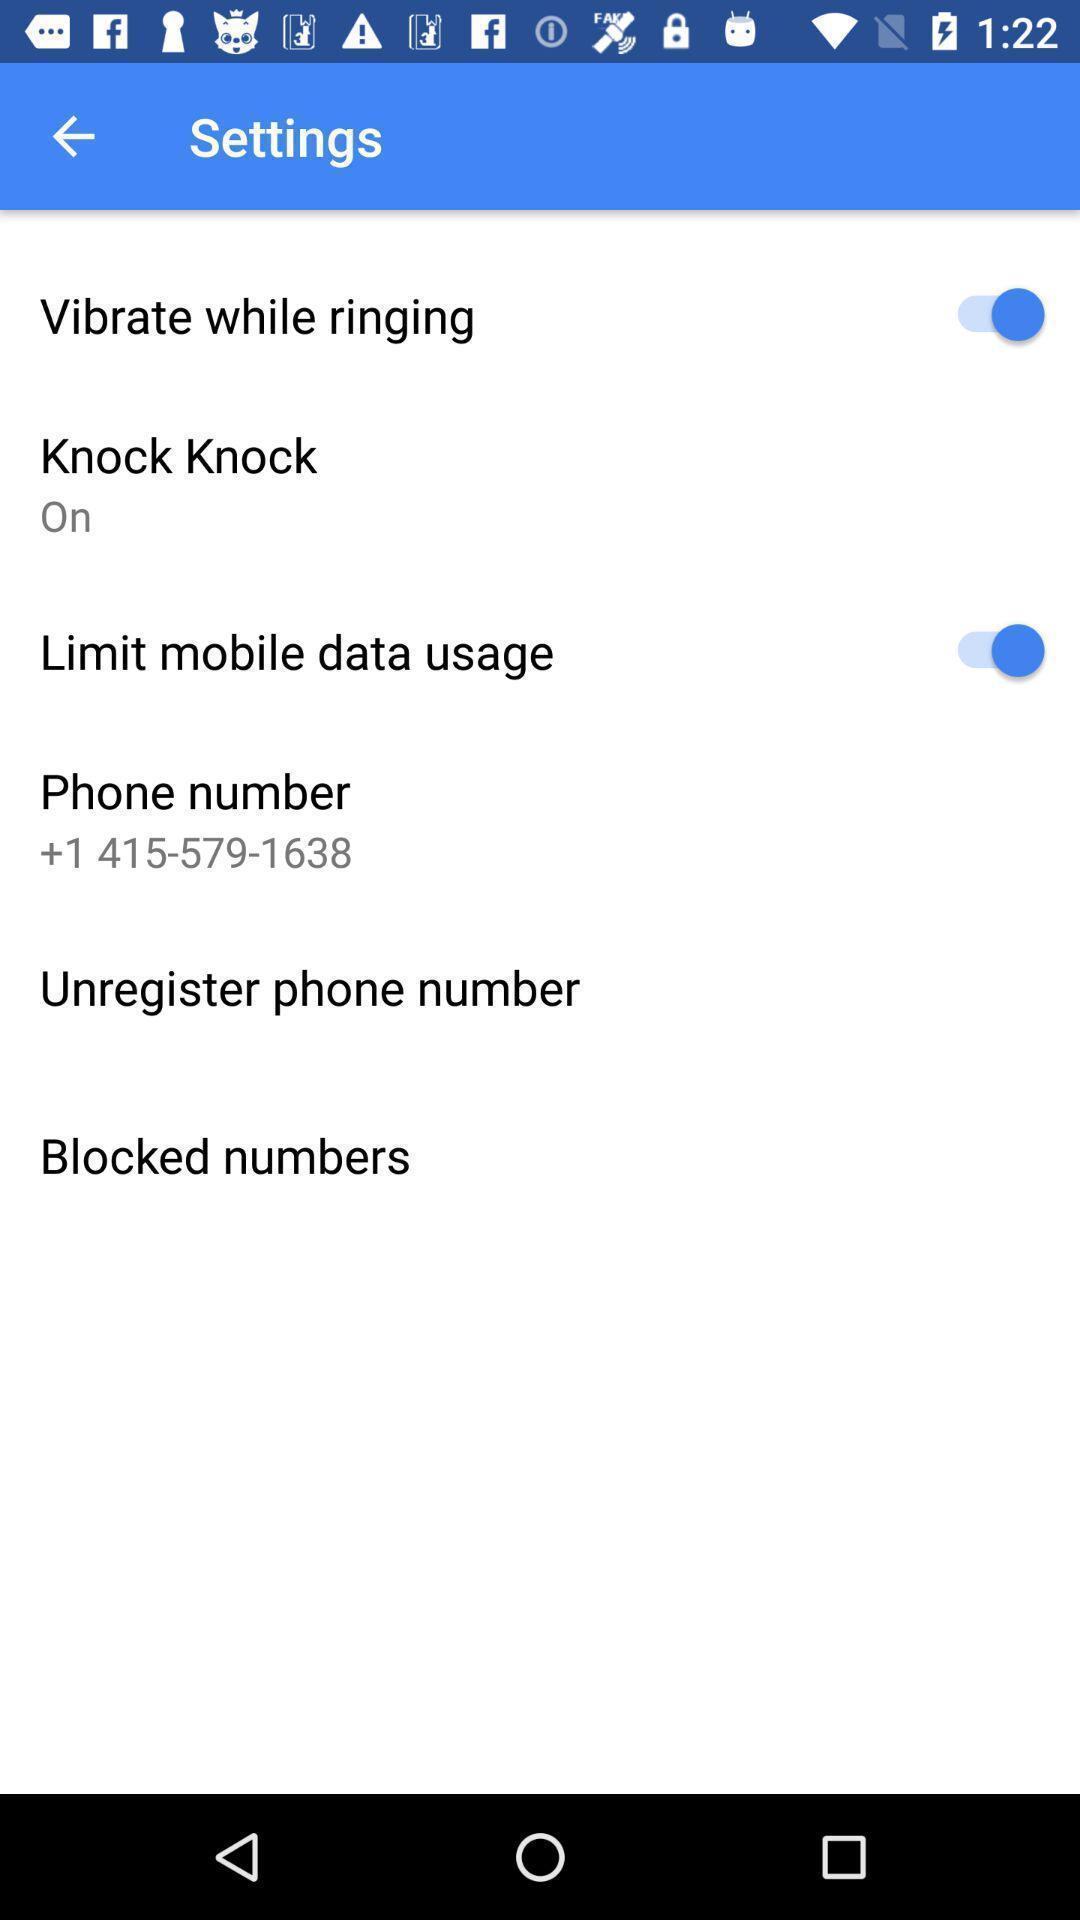Describe this image in words. Settings page of a calling app. 